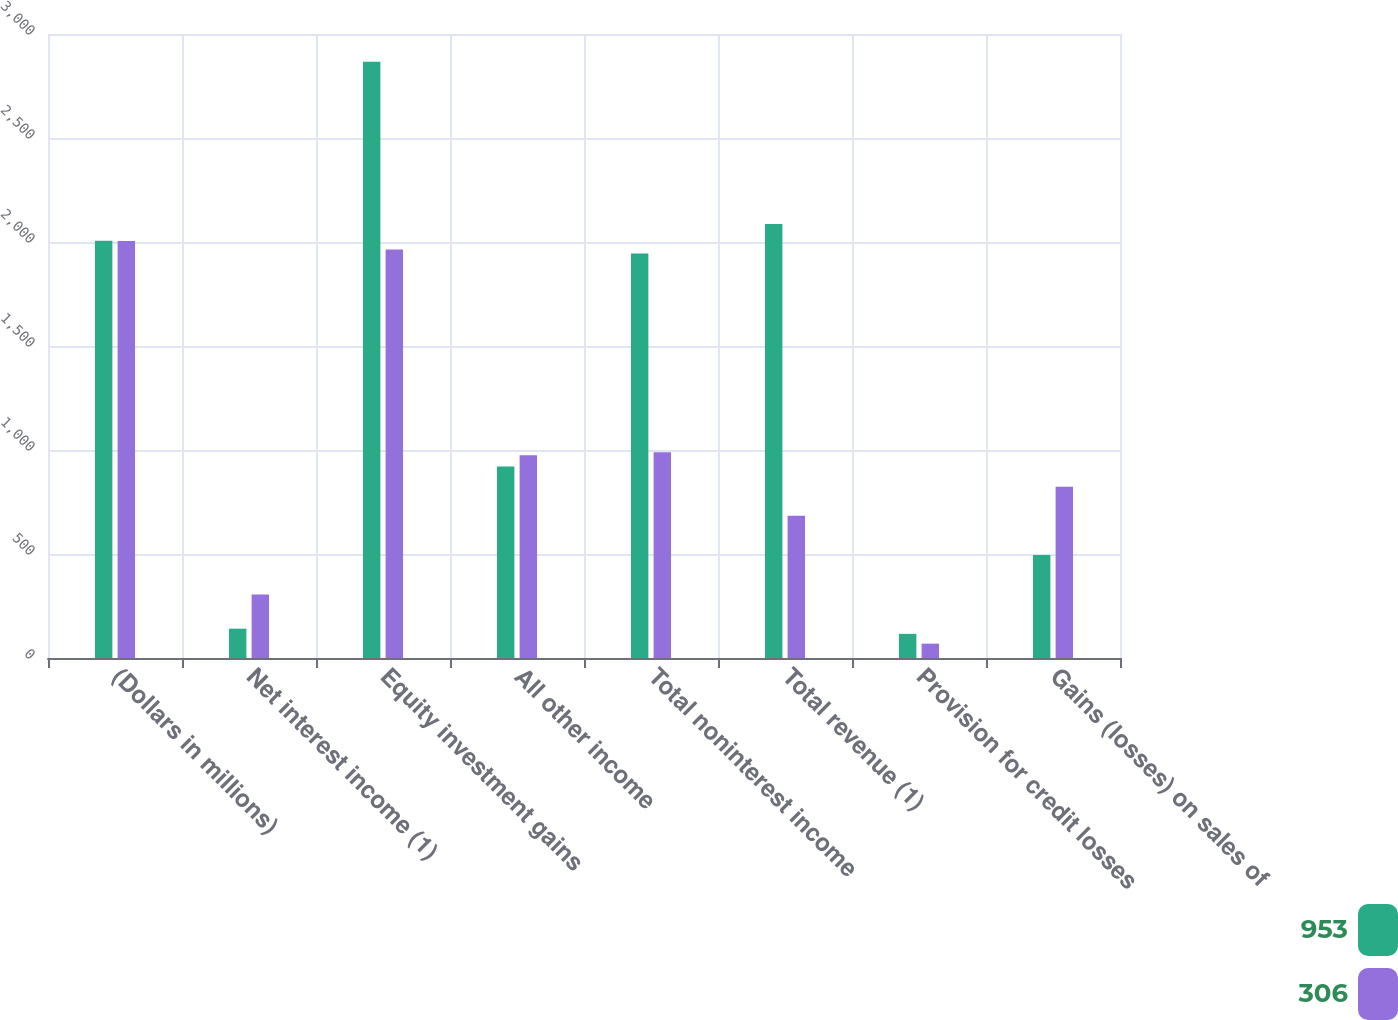<chart> <loc_0><loc_0><loc_500><loc_500><stacked_bar_chart><ecel><fcel>(Dollars in millions)<fcel>Net interest income (1)<fcel>Equity investment gains<fcel>All other income<fcel>Total noninterest income<fcel>Total revenue (1)<fcel>Provision for credit losses<fcel>Gains (losses) on sales of<nl><fcel>953<fcel>2006<fcel>141<fcel>2866<fcel>921<fcel>1945<fcel>2086<fcel>116<fcel>495<nl><fcel>306<fcel>2005<fcel>305<fcel>1964<fcel>975<fcel>989<fcel>684<fcel>69<fcel>823<nl></chart> 